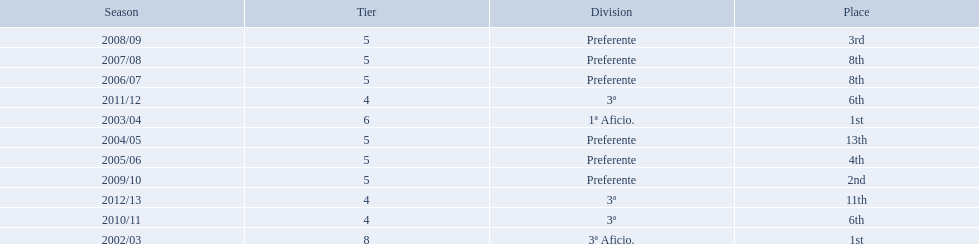How many times did  internacional de madrid cf come in 6th place? 6th, 6th. What is the first season that the team came in 6th place? 2010/11. Which season after the first did they place in 6th again? 2011/12. 